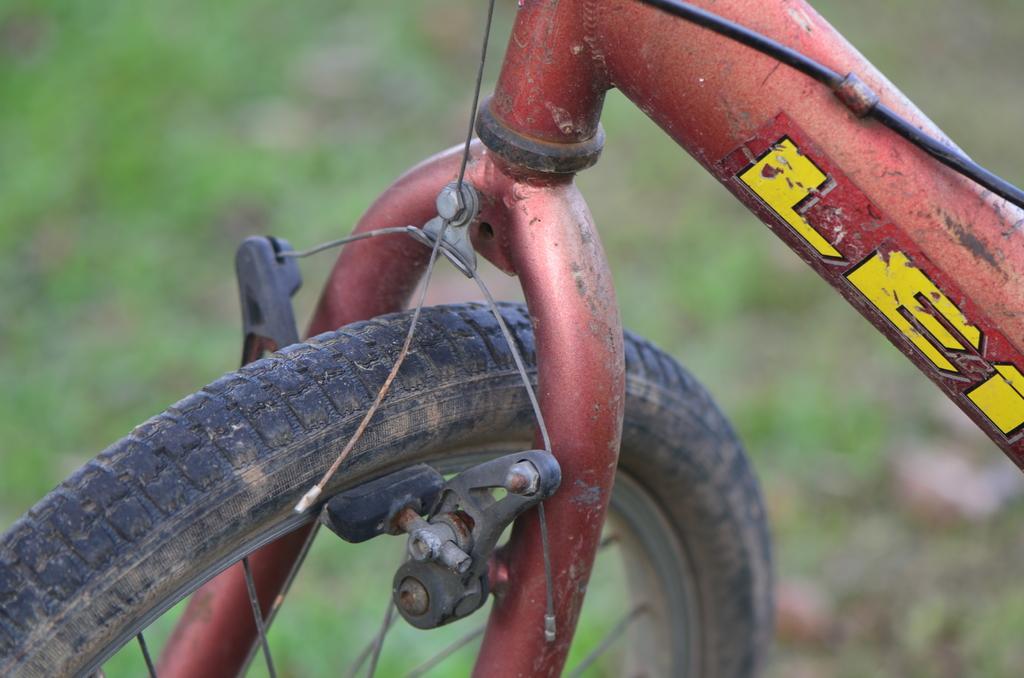How would you summarize this image in a sentence or two? In this foreground we can see a bicycle. In the background there is greenery. 